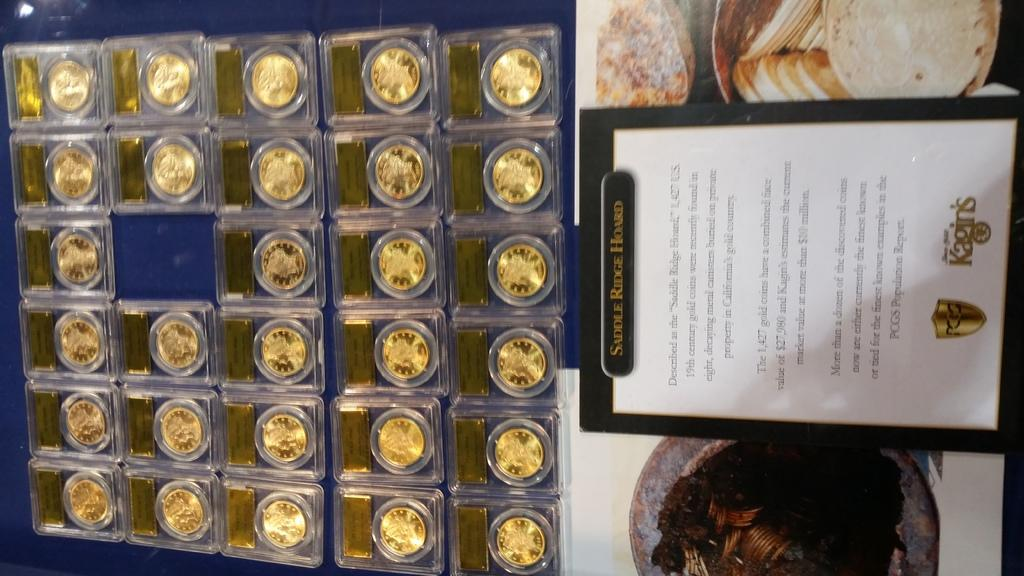<image>
Provide a brief description of the given image. gold coins in a case that reads Saddle Ridge Hoard 